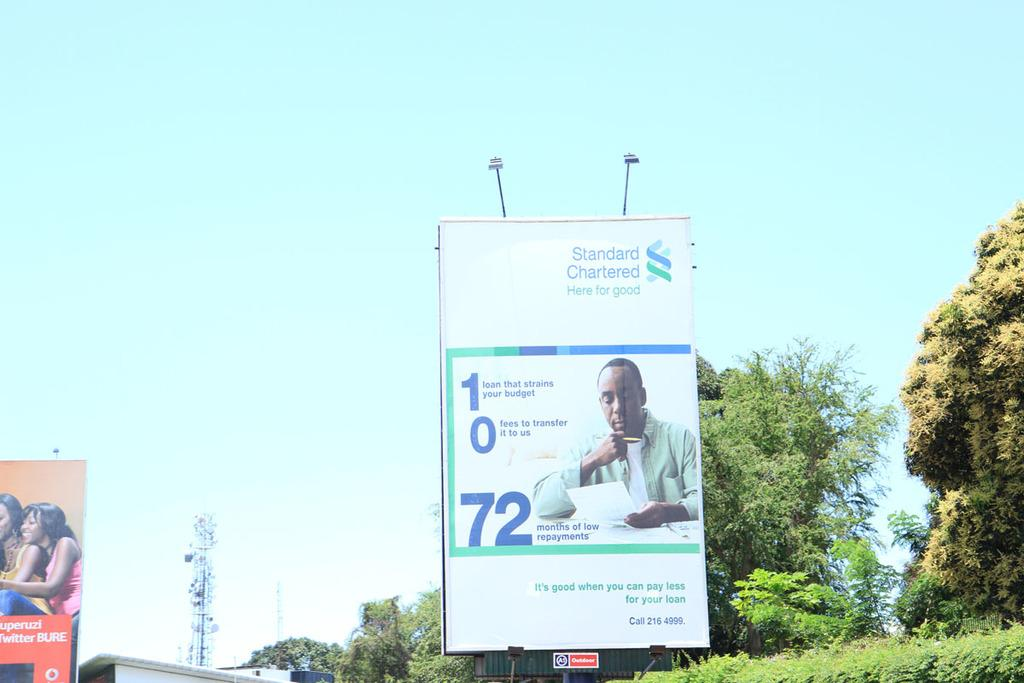<image>
Give a short and clear explanation of the subsequent image. An advertistment for Standard Chartered healthcare on the road. 